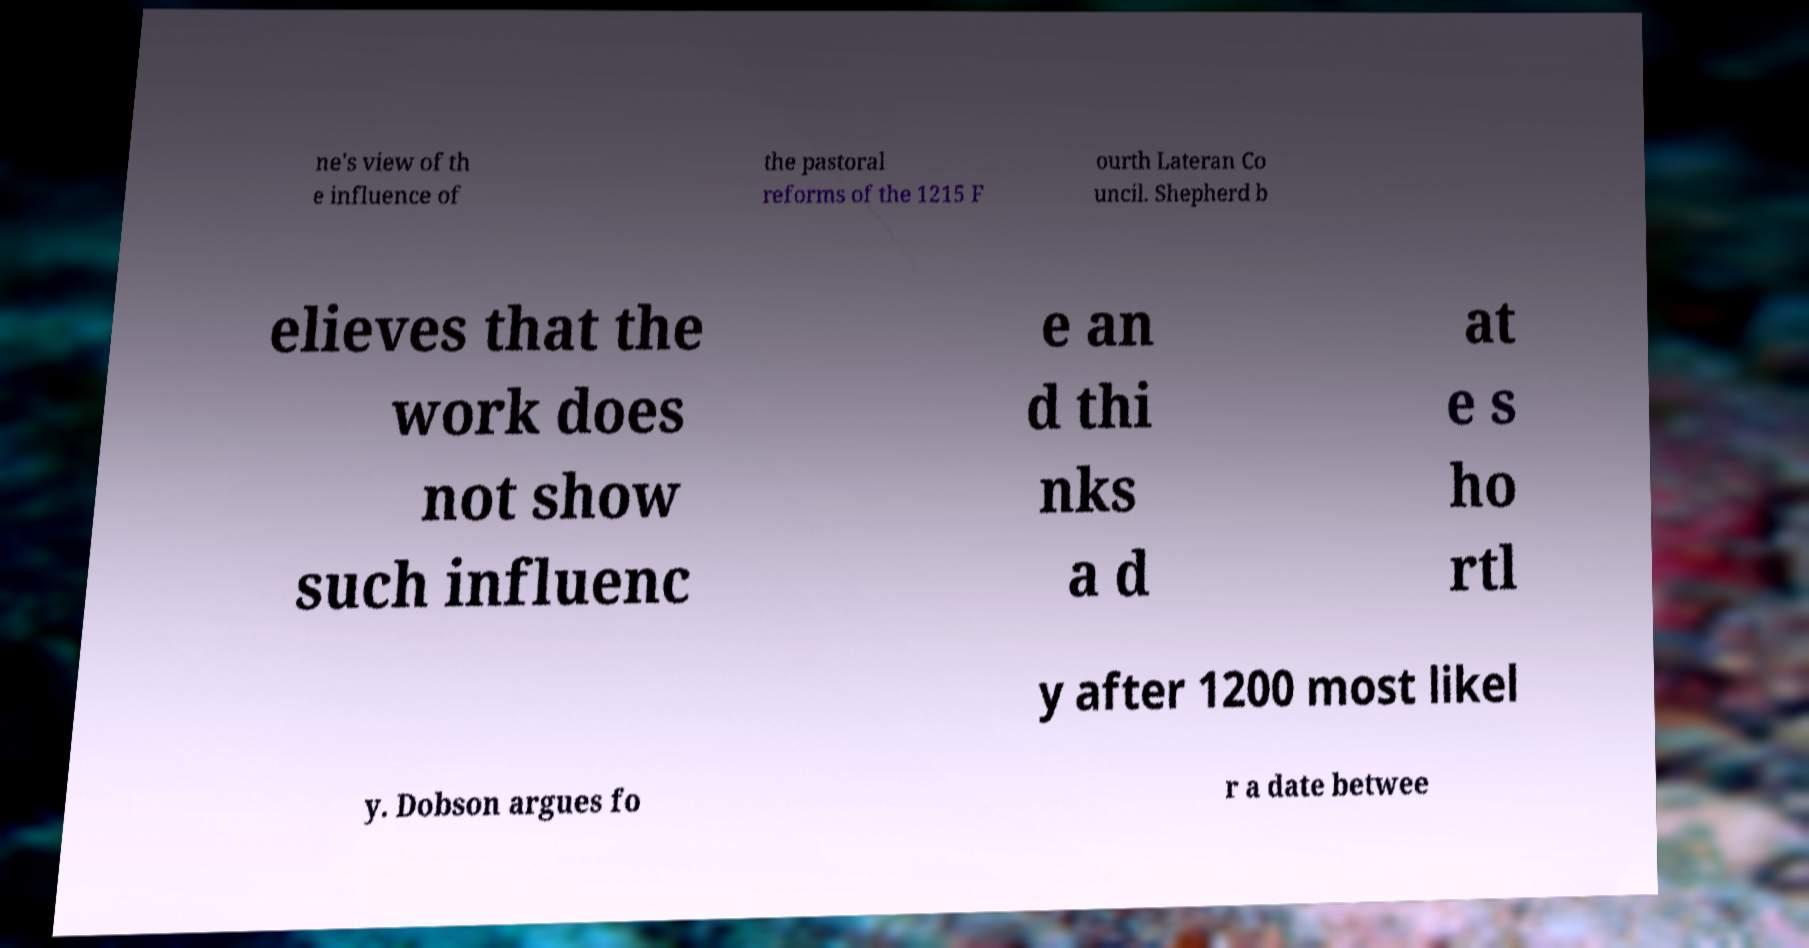Could you assist in decoding the text presented in this image and type it out clearly? ne's view of th e influence of the pastoral reforms of the 1215 F ourth Lateran Co uncil. Shepherd b elieves that the work does not show such influenc e an d thi nks a d at e s ho rtl y after 1200 most likel y. Dobson argues fo r a date betwee 